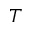Convert formula to latex. <formula><loc_0><loc_0><loc_500><loc_500>T</formula> 